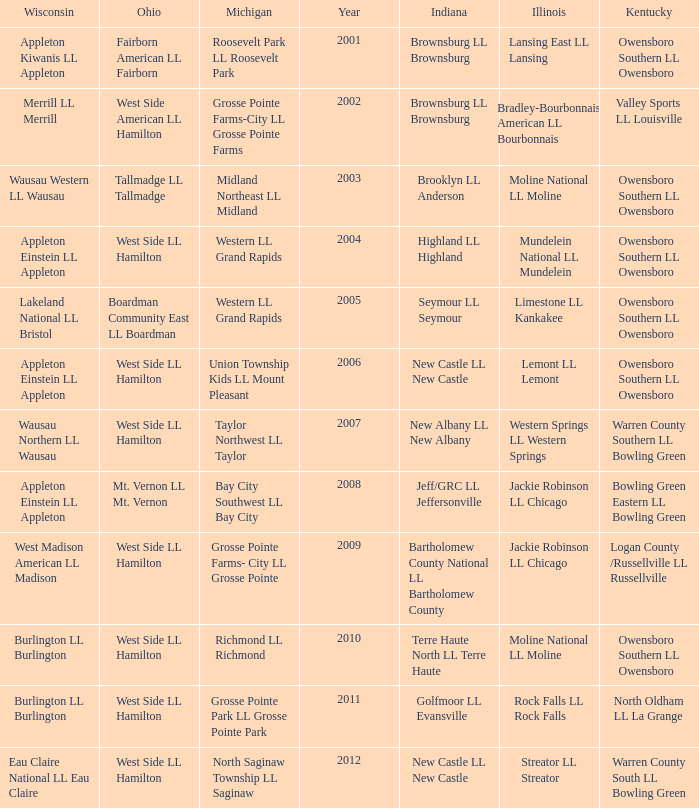What was the little league team from Indiana when the little league team from Michigan was Midland Northeast LL Midland? Brooklyn LL Anderson. 